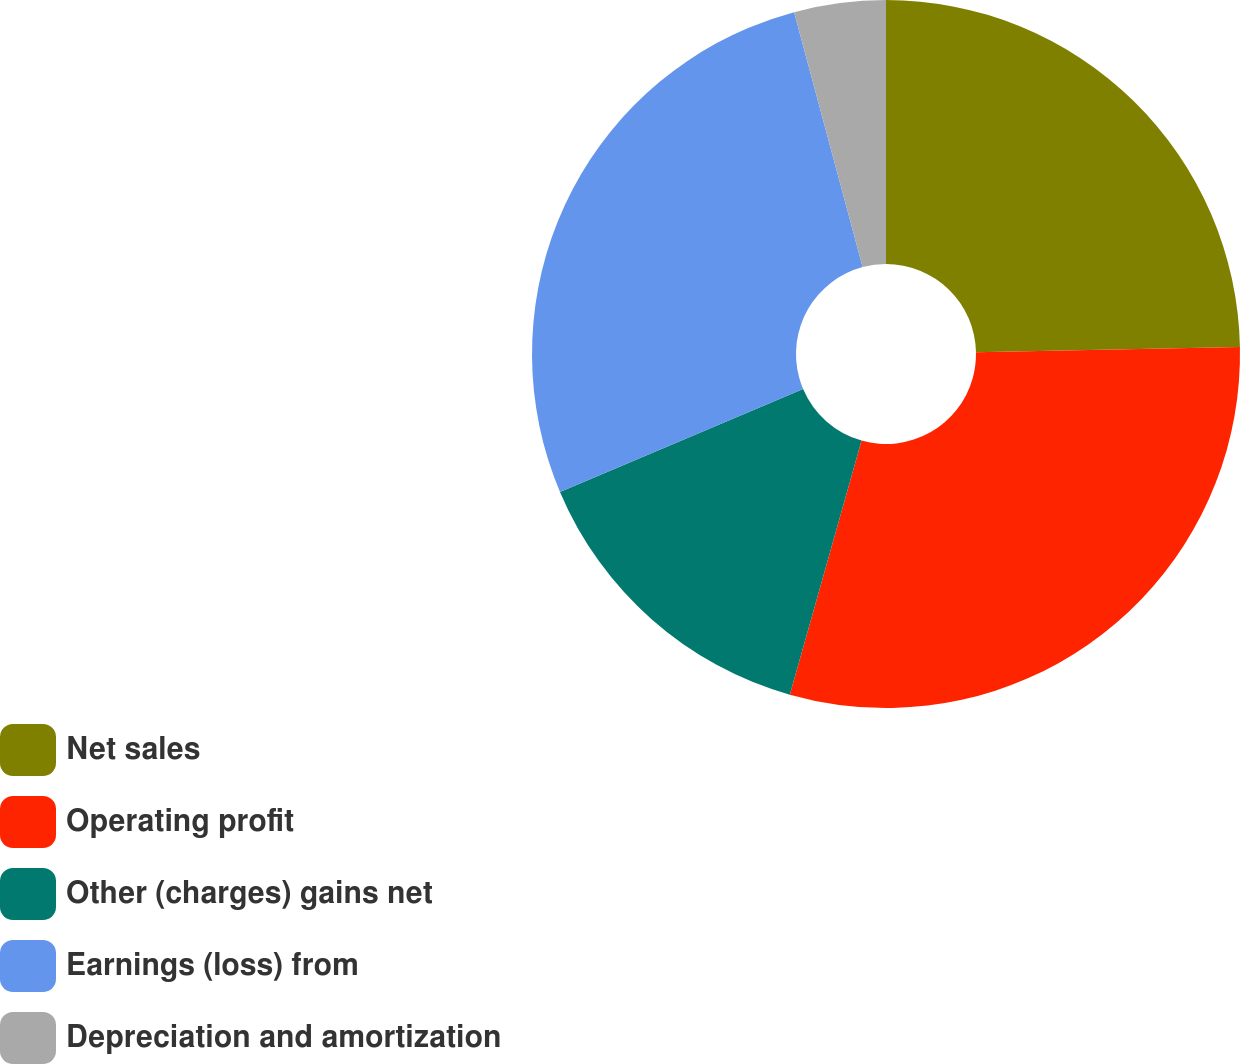<chart> <loc_0><loc_0><loc_500><loc_500><pie_chart><fcel>Net sales<fcel>Operating profit<fcel>Other (charges) gains net<fcel>Earnings (loss) from<fcel>Depreciation and amortization<nl><fcel>24.69%<fcel>29.69%<fcel>14.25%<fcel>27.19%<fcel>4.18%<nl></chart> 